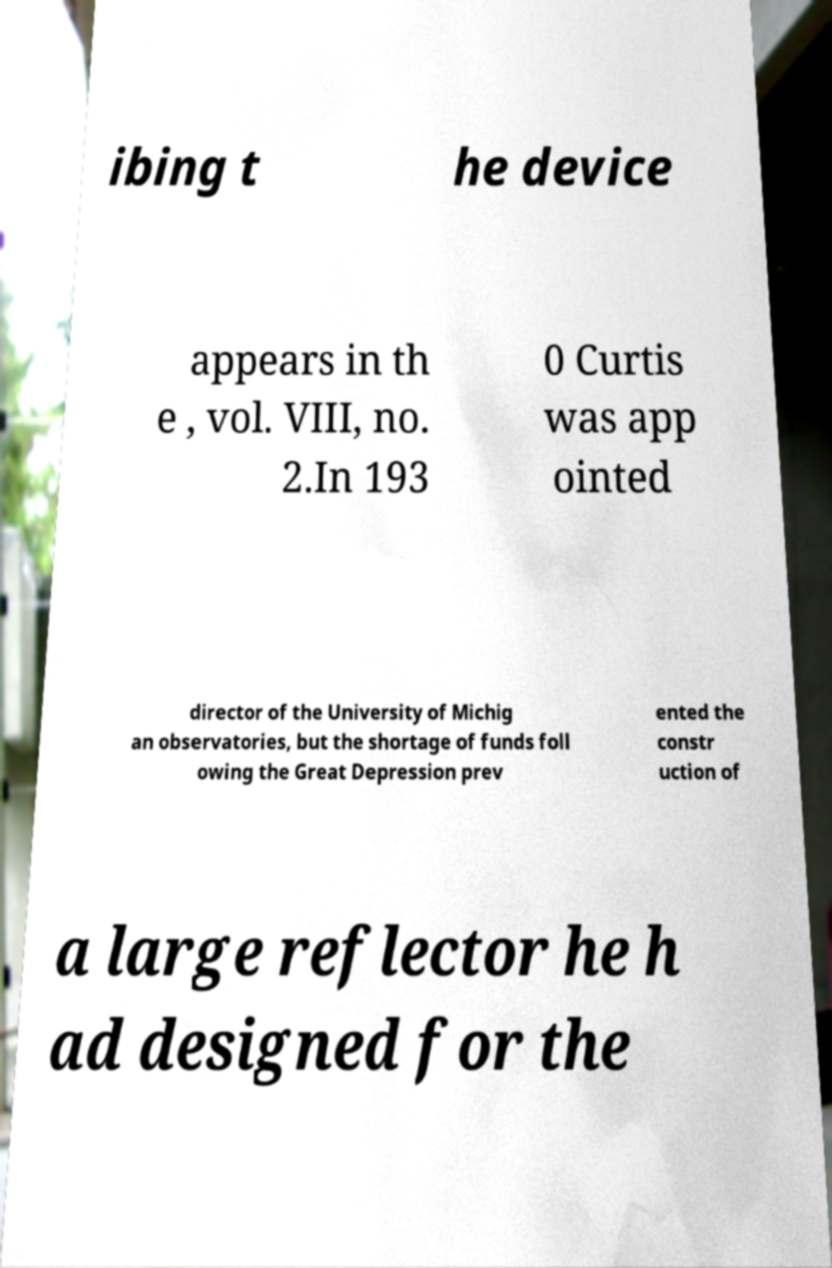There's text embedded in this image that I need extracted. Can you transcribe it verbatim? ibing t he device appears in th e , vol. VIII, no. 2.In 193 0 Curtis was app ointed director of the University of Michig an observatories, but the shortage of funds foll owing the Great Depression prev ented the constr uction of a large reflector he h ad designed for the 